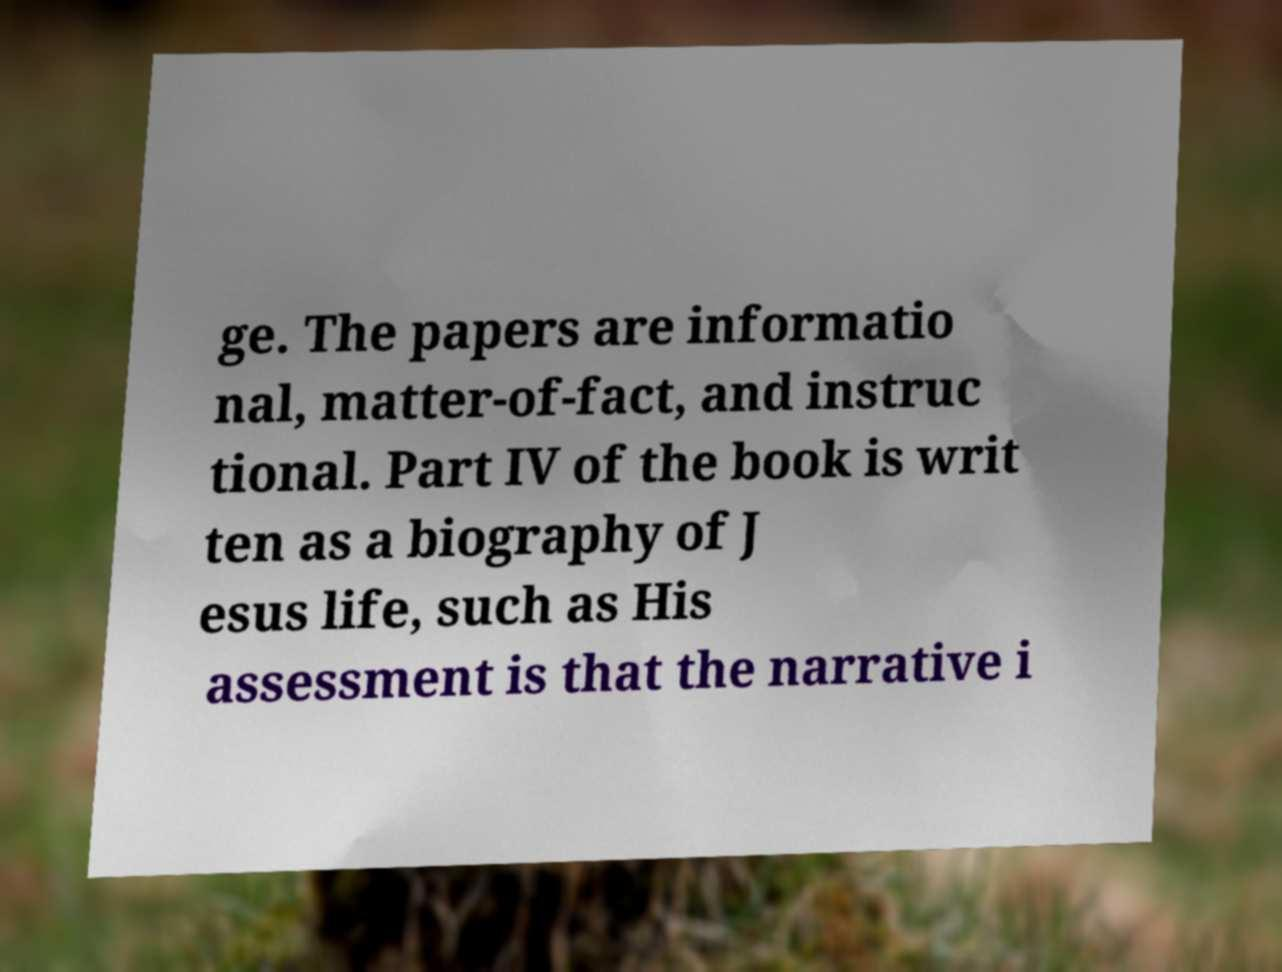What messages or text are displayed in this image? I need them in a readable, typed format. ge. The papers are informatio nal, matter-of-fact, and instruc tional. Part IV of the book is writ ten as a biography of J esus life, such as His assessment is that the narrative i 